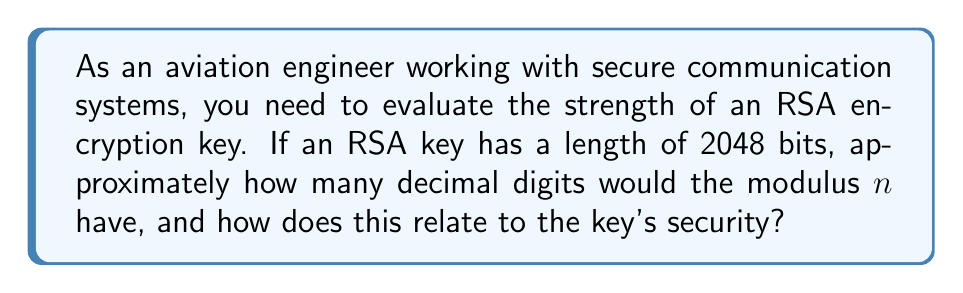Could you help me with this problem? To evaluate the strength of an RSA encryption key based on its bit length, we need to understand the relationship between bit length and the number of decimal digits. Let's break this down step-by-step:

1. The RSA key length refers to the bit length of the modulus $n$, where $n = pq$ (p and q are large prime numbers).

2. To convert from bits to decimal digits, we can use the following approximation:
   $\text{Number of decimal digits} \approx \text{Number of bits} \times \log_{10}(2)$

3. For a 2048-bit key:
   $\text{Number of decimal digits} \approx 2048 \times \log_{10}(2)$
   $\approx 2048 \times 0.301$
   $\approx 616.4$

4. Rounding up, we get approximately 617 decimal digits.

5. The security of RSA is based on the difficulty of factoring large numbers. As the number of digits increases, the factorization becomes exponentially more difficult.

6. Currently, keys of 2048 bits are considered secure for most applications, including those in aviation. They offer a good balance between security and computational efficiency.

7. For comparison:
   - 1024-bit keys (about 309 digits) are now considered weak.
   - 3072-bit keys (about 925 digits) are recommended for longer-term security.
   - 4096-bit keys (about 1234 digits) offer even stronger security but at the cost of increased computational load.

8. In aviation, where both security and system performance are critical, 2048-bit keys provide a strong level of security without overly burdening communication systems.
Answer: Approximately 617 decimal digits; considered secure for most current applications, including aviation systems. 